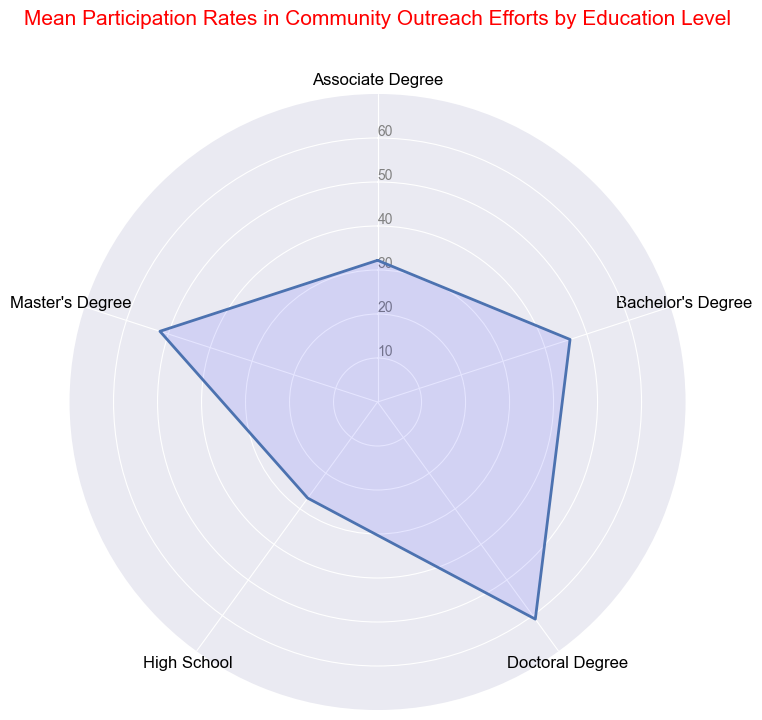What's the highest mean participation rate seen in the chart? The highest mean participation rate can be determined by looking at the outermost point on the chart. According to the chart, this is for the Doctoral Degree with a value of 61.
Answer: 61 Which education level has the lowest mean participation rate? The lowest mean participation rate can be observed at the innermost point of the chart. This corresponds to High School with a mean participation rate of 27.
Answer: High School By how much does the mean participation rate for a Master’s Degree exceed that of a Bachelor’s Degree? The chart shows the mean participation rate for a Master’s Degree is 52, while for a Bachelor’s Degree, it is 46. The difference can be calculated as 52 - 46 = 6.
Answer: 6 Which education levels show a mean participation rate between 30 and 50? By examining the chart, we can see that the mean participation rates that fall between 30 and 50 correspond to Associate Degree (32), Bachelor’s Degree (46), and Master’s Degree (52) falls just outside the range.
Answer: Associate Degree, Bachelor's Degree Are mean participation rates strictly increasing with higher education levels? To check this, we compare the education levels in ascending order: High School (27), Associate Degree (32), Bachelor’s Degree (46), Master’s Degree (52), and Doctoral Degree (61). The values increase consistently, meaning yes.
Answer: Yes What is the mean participation rate for education levels up to Associate Degree? The mean participation rates for High School is 27 and for Associate Degree is 32. The combined mean can be calculated as (27 + 32) / 2 = 29.5.
Answer: 29.5 How does the mean participation rate for Bachelor’s Degree compare to that for High School? According to the chart, the mean participation rate for a Bachelor’s Degree is 46, whereas for High School, it is 27. The Bachelor’s Degree rate is significantly higher by 19 points.
Answer: 19 points higher Which education level has a mean participation rate closest to 50? By observing the chart, the education level with a mean participation rate closest to 50 is Master's Degree, which has a mean participation rate of 52.
Answer: Master’s Degree What is the average of the mean participation rates for all education levels combined? The mean participation rates are: High School (27), Associate Degree (32), Bachelor’s Degree (46), Master’s Degree (52), and Doctoral Degree (61). The combined average can be calculated as (27 + 32 + 46 + 52 + 61) / 5 = 43.6.
Answer: 43.6 What is the difference between the highest and lowest mean participation rates shown in the chart? The difference can be calculated by subtracting the lowest mean participation rate (High School, 27) from the highest (Doctoral Degree, 61). Thus, 61 - 27 = 34.
Answer: 34 